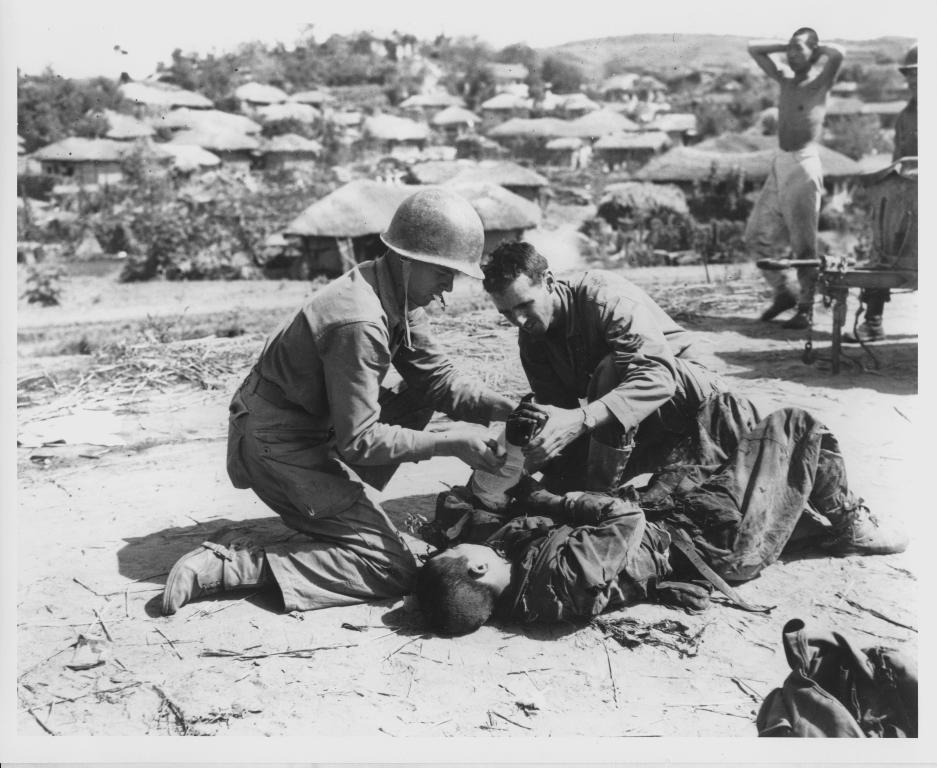Can you describe this image briefly? In this image we can see a man lying on the ground and there are two people sitting and holding a bottle. In the background there are seeds and trees. On the right we can see people walking and there is a bench. 